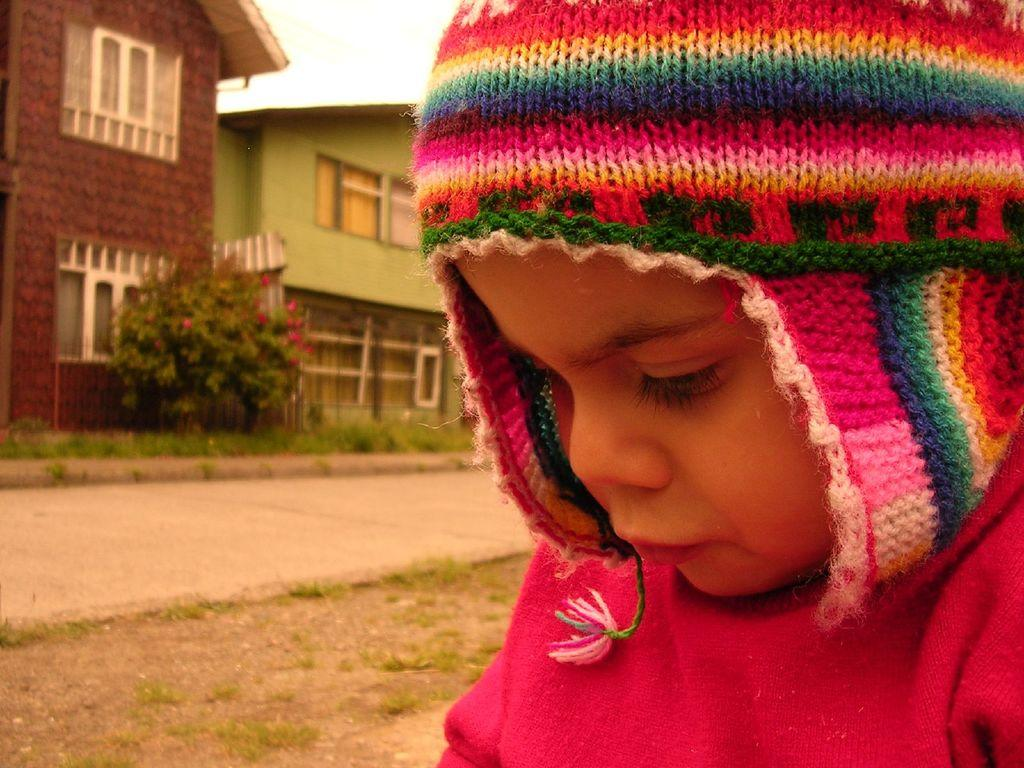What is the main subject of the image? The main subject of the image is a kid. What is the kid wearing on their head? The kid is wearing a monkey cap. What can be seen in the background of the image? There is grass, a plant with flowers, houses, and the sky visible in the background of the image. What type of pets can be seen playing with the kid in the image? There are no pets visible in the image; it only features a kid wearing a monkey cap and the background elements mentioned earlier. 